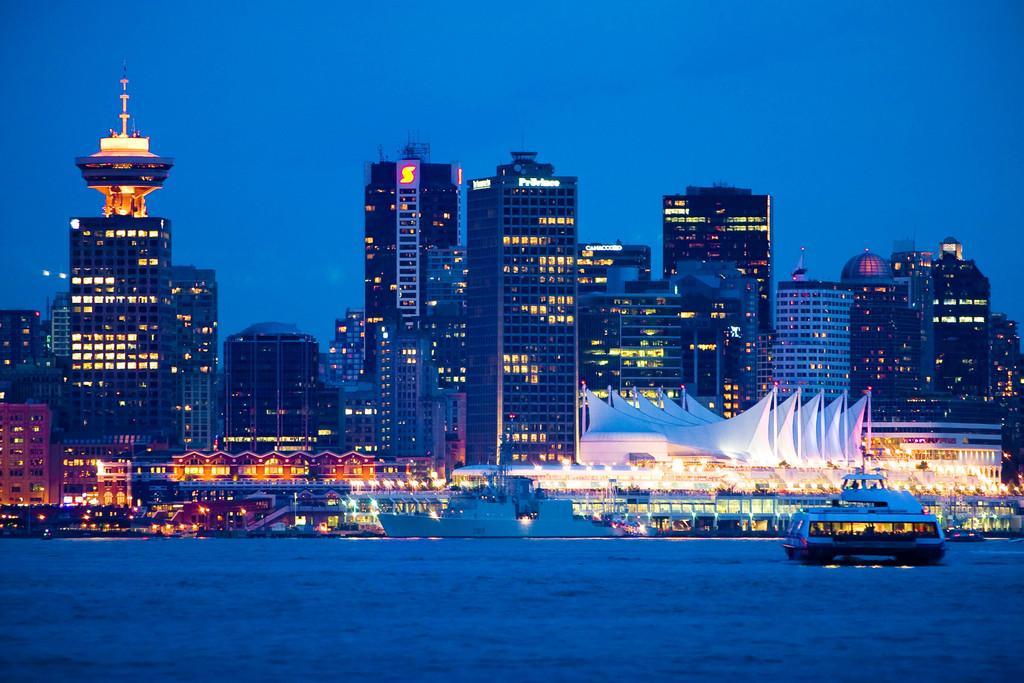How would you summarize this image in a sentence or two? In this picture we can see water and we can see a boat on the right side and we can see houses in the background and tall buildings and we can see dull the sky on the top. 